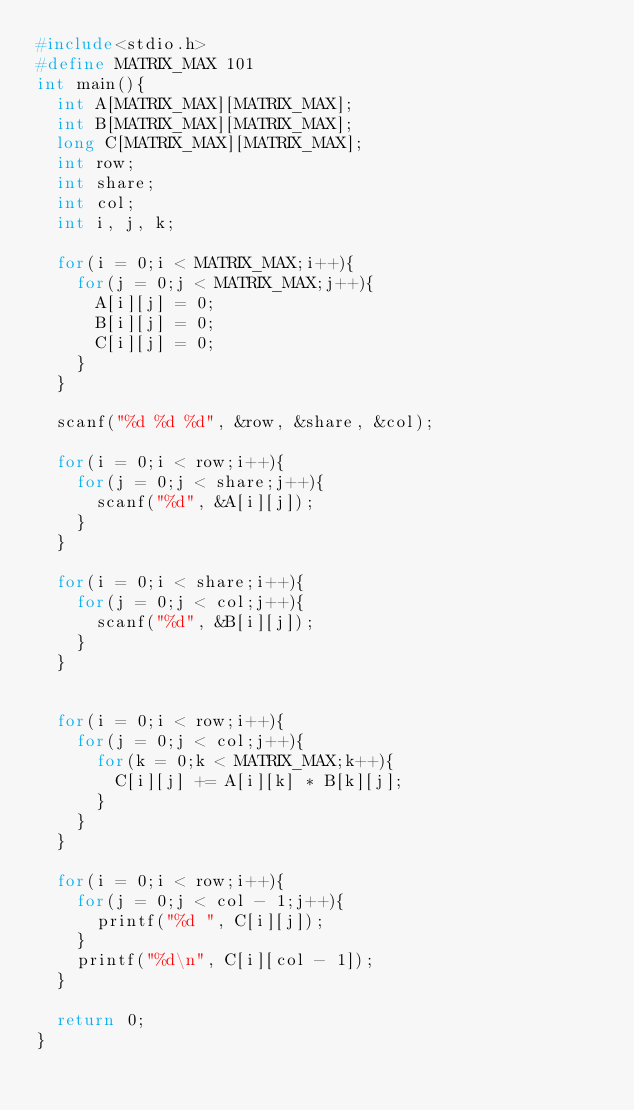<code> <loc_0><loc_0><loc_500><loc_500><_C_>#include<stdio.h>
#define MATRIX_MAX 101
int main(){
	int A[MATRIX_MAX][MATRIX_MAX];
	int B[MATRIX_MAX][MATRIX_MAX];
	long C[MATRIX_MAX][MATRIX_MAX];
	int row;
	int share;
	int col;
	int i, j, k;
	
	for(i = 0;i < MATRIX_MAX;i++){
		for(j = 0;j < MATRIX_MAX;j++){
			A[i][j] = 0;
			B[i][j] = 0;
			C[i][j] = 0;
		}
	}
	
	scanf("%d %d %d", &row, &share, &col);
	
	for(i = 0;i < row;i++){
		for(j = 0;j < share;j++){
			scanf("%d", &A[i][j]);
		}
	}
	
	for(i = 0;i < share;i++){
		for(j = 0;j < col;j++){
			scanf("%d", &B[i][j]);
		}
	}
	

	for(i = 0;i < row;i++){
		for(j = 0;j < col;j++){
			for(k = 0;k < MATRIX_MAX;k++){
				C[i][j] += A[i][k] * B[k][j];
			}
		}
	}
	
	for(i = 0;i < row;i++){
		for(j = 0;j < col - 1;j++){
			printf("%d ", C[i][j]);
		}
		printf("%d\n", C[i][col - 1]);
	}
	
	return 0;
}


</code> 